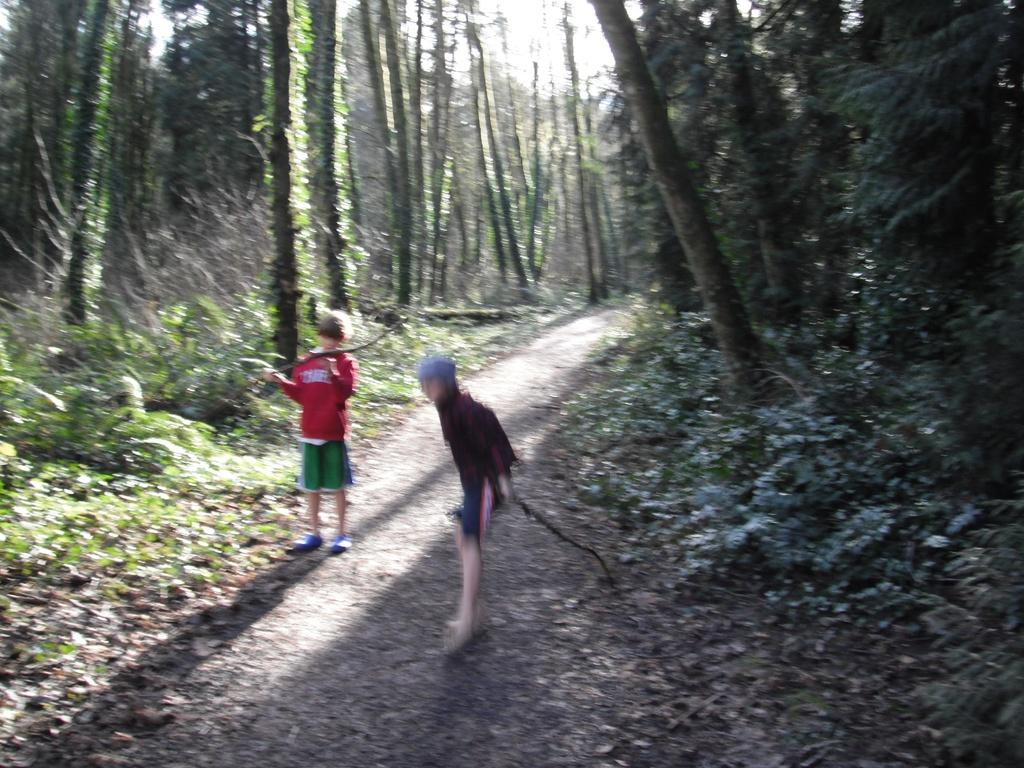How many people are in the image? There are two boys in the image. Where are the boys located? The boys are on a path in between a forest. What can be seen in the forest? There are many tall trees in the forest. What are the boys holding in their hands? The boys are holding sticks in their hands. What type of wrist accessories are the boys wearing in the image? There is no mention of wrist accessories in the image; the boys are holding sticks in their hands. 